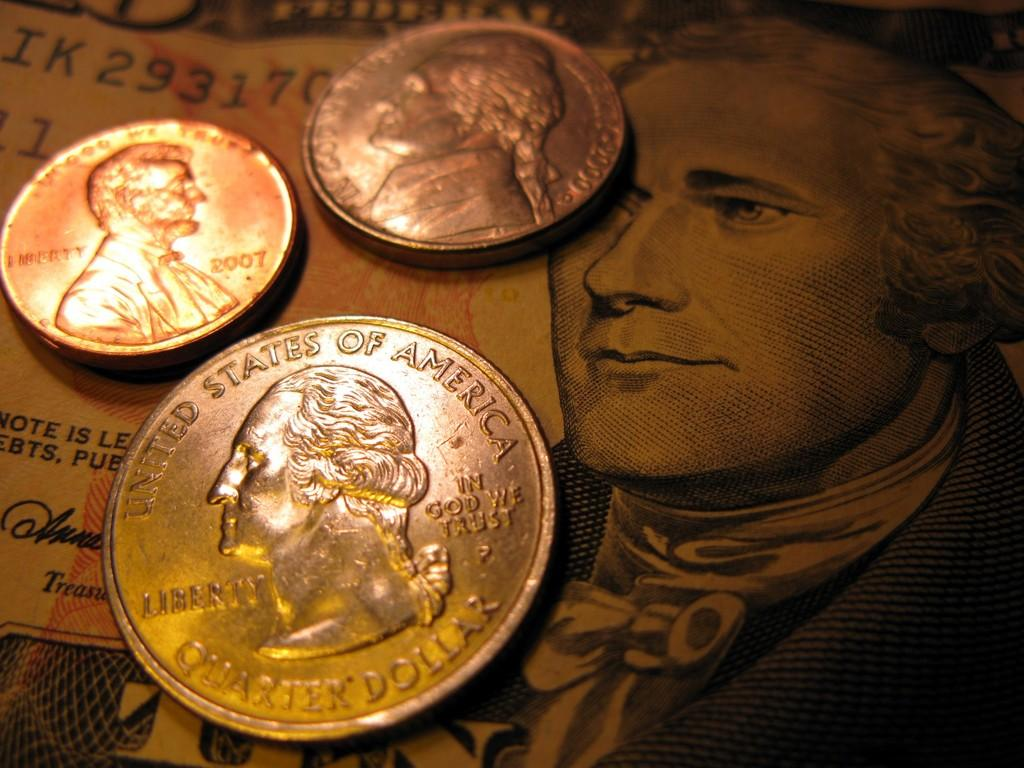Provide a one-sentence caption for the provided image. United States of America quarter dollar silver coin. 